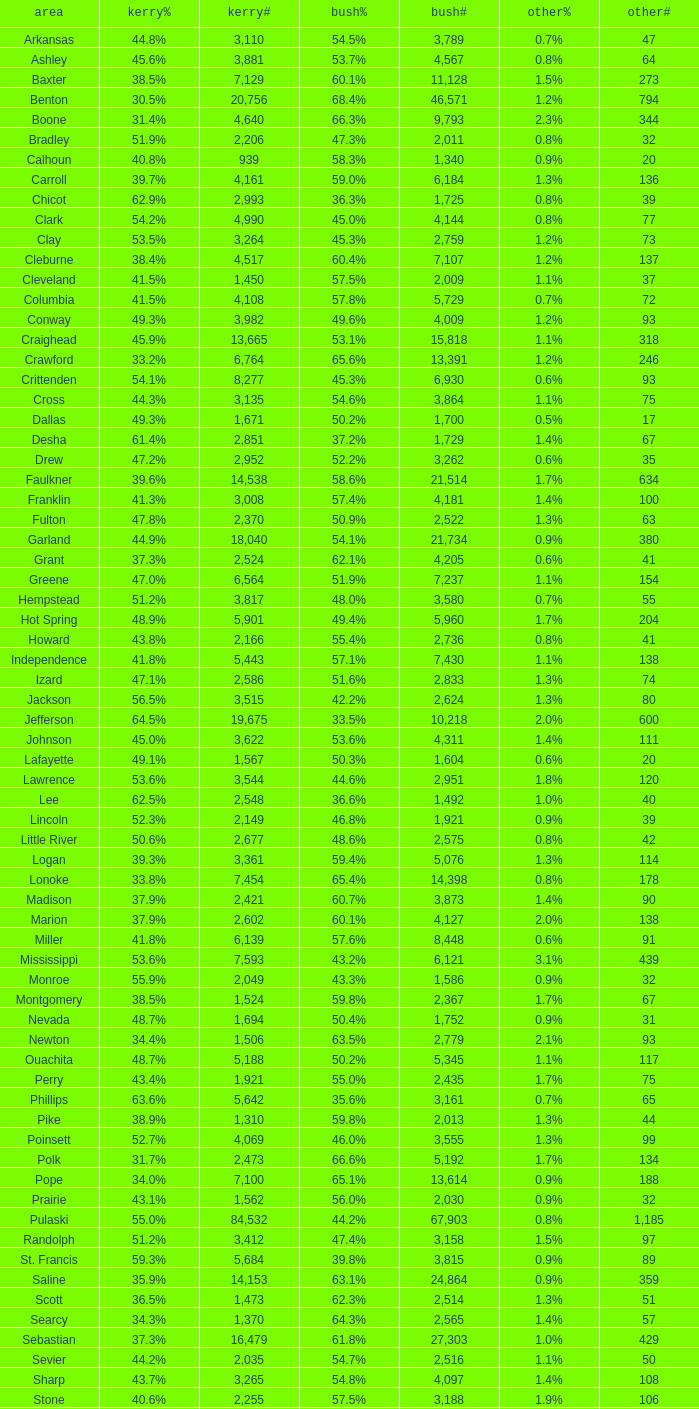What is the highest Bush#, when Others% is "1.7%", when Others# is less than 75, and when Kerry# is greater than 1,524? None. 